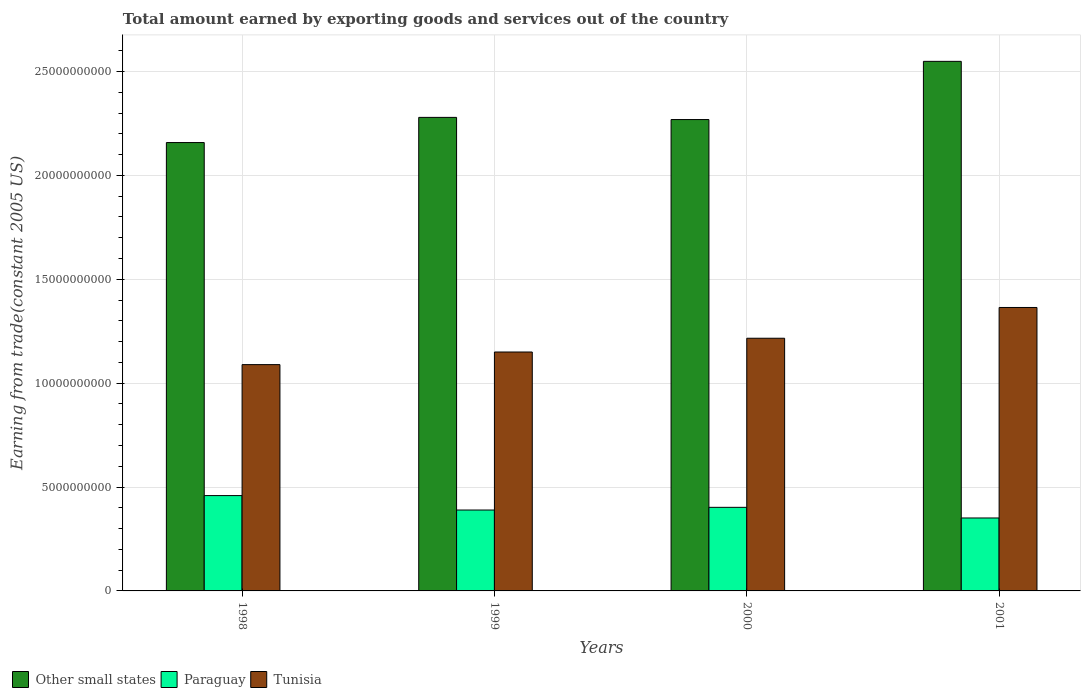How many different coloured bars are there?
Your answer should be very brief. 3. How many groups of bars are there?
Your response must be concise. 4. Are the number of bars per tick equal to the number of legend labels?
Your response must be concise. Yes. Are the number of bars on each tick of the X-axis equal?
Give a very brief answer. Yes. How many bars are there on the 2nd tick from the left?
Ensure brevity in your answer.  3. What is the label of the 4th group of bars from the left?
Give a very brief answer. 2001. What is the total amount earned by exporting goods and services in Other small states in 2000?
Offer a terse response. 2.27e+1. Across all years, what is the maximum total amount earned by exporting goods and services in Tunisia?
Your answer should be compact. 1.36e+1. Across all years, what is the minimum total amount earned by exporting goods and services in Tunisia?
Your response must be concise. 1.09e+1. In which year was the total amount earned by exporting goods and services in Tunisia maximum?
Keep it short and to the point. 2001. In which year was the total amount earned by exporting goods and services in Other small states minimum?
Your answer should be compact. 1998. What is the total total amount earned by exporting goods and services in Paraguay in the graph?
Offer a terse response. 1.60e+1. What is the difference between the total amount earned by exporting goods and services in Paraguay in 1998 and that in 1999?
Give a very brief answer. 6.95e+08. What is the difference between the total amount earned by exporting goods and services in Other small states in 2000 and the total amount earned by exporting goods and services in Tunisia in 1998?
Your answer should be compact. 1.18e+1. What is the average total amount earned by exporting goods and services in Paraguay per year?
Your answer should be very brief. 4.00e+09. In the year 2001, what is the difference between the total amount earned by exporting goods and services in Tunisia and total amount earned by exporting goods and services in Other small states?
Offer a very short reply. -1.18e+1. In how many years, is the total amount earned by exporting goods and services in Other small states greater than 1000000000 US$?
Your answer should be compact. 4. What is the ratio of the total amount earned by exporting goods and services in Paraguay in 1998 to that in 2000?
Your answer should be compact. 1.14. Is the total amount earned by exporting goods and services in Paraguay in 1999 less than that in 2001?
Your response must be concise. No. What is the difference between the highest and the second highest total amount earned by exporting goods and services in Tunisia?
Ensure brevity in your answer.  1.48e+09. What is the difference between the highest and the lowest total amount earned by exporting goods and services in Tunisia?
Offer a terse response. 2.75e+09. In how many years, is the total amount earned by exporting goods and services in Other small states greater than the average total amount earned by exporting goods and services in Other small states taken over all years?
Ensure brevity in your answer.  1. Is the sum of the total amount earned by exporting goods and services in Paraguay in 1998 and 2000 greater than the maximum total amount earned by exporting goods and services in Other small states across all years?
Your answer should be very brief. No. What does the 3rd bar from the left in 2001 represents?
Make the answer very short. Tunisia. What does the 3rd bar from the right in 1999 represents?
Ensure brevity in your answer.  Other small states. Are all the bars in the graph horizontal?
Offer a very short reply. No. How many years are there in the graph?
Your response must be concise. 4. Does the graph contain any zero values?
Ensure brevity in your answer.  No. Where does the legend appear in the graph?
Offer a terse response. Bottom left. How are the legend labels stacked?
Offer a very short reply. Horizontal. What is the title of the graph?
Keep it short and to the point. Total amount earned by exporting goods and services out of the country. What is the label or title of the Y-axis?
Keep it short and to the point. Earning from trade(constant 2005 US). What is the Earning from trade(constant 2005 US) in Other small states in 1998?
Offer a very short reply. 2.16e+1. What is the Earning from trade(constant 2005 US) in Paraguay in 1998?
Keep it short and to the point. 4.59e+09. What is the Earning from trade(constant 2005 US) in Tunisia in 1998?
Offer a very short reply. 1.09e+1. What is the Earning from trade(constant 2005 US) of Other small states in 1999?
Your response must be concise. 2.28e+1. What is the Earning from trade(constant 2005 US) in Paraguay in 1999?
Provide a succinct answer. 3.89e+09. What is the Earning from trade(constant 2005 US) of Tunisia in 1999?
Offer a very short reply. 1.15e+1. What is the Earning from trade(constant 2005 US) in Other small states in 2000?
Your response must be concise. 2.27e+1. What is the Earning from trade(constant 2005 US) of Paraguay in 2000?
Offer a terse response. 4.02e+09. What is the Earning from trade(constant 2005 US) of Tunisia in 2000?
Provide a succinct answer. 1.22e+1. What is the Earning from trade(constant 2005 US) in Other small states in 2001?
Your answer should be compact. 2.55e+1. What is the Earning from trade(constant 2005 US) in Paraguay in 2001?
Provide a short and direct response. 3.51e+09. What is the Earning from trade(constant 2005 US) of Tunisia in 2001?
Your response must be concise. 1.36e+1. Across all years, what is the maximum Earning from trade(constant 2005 US) in Other small states?
Ensure brevity in your answer.  2.55e+1. Across all years, what is the maximum Earning from trade(constant 2005 US) of Paraguay?
Your answer should be compact. 4.59e+09. Across all years, what is the maximum Earning from trade(constant 2005 US) in Tunisia?
Keep it short and to the point. 1.36e+1. Across all years, what is the minimum Earning from trade(constant 2005 US) in Other small states?
Offer a terse response. 2.16e+1. Across all years, what is the minimum Earning from trade(constant 2005 US) in Paraguay?
Give a very brief answer. 3.51e+09. Across all years, what is the minimum Earning from trade(constant 2005 US) of Tunisia?
Ensure brevity in your answer.  1.09e+1. What is the total Earning from trade(constant 2005 US) in Other small states in the graph?
Give a very brief answer. 9.25e+1. What is the total Earning from trade(constant 2005 US) of Paraguay in the graph?
Give a very brief answer. 1.60e+1. What is the total Earning from trade(constant 2005 US) of Tunisia in the graph?
Your answer should be very brief. 4.82e+1. What is the difference between the Earning from trade(constant 2005 US) in Other small states in 1998 and that in 1999?
Keep it short and to the point. -1.21e+09. What is the difference between the Earning from trade(constant 2005 US) in Paraguay in 1998 and that in 1999?
Offer a very short reply. 6.95e+08. What is the difference between the Earning from trade(constant 2005 US) of Tunisia in 1998 and that in 1999?
Your answer should be compact. -6.07e+08. What is the difference between the Earning from trade(constant 2005 US) of Other small states in 1998 and that in 2000?
Offer a terse response. -1.11e+09. What is the difference between the Earning from trade(constant 2005 US) in Paraguay in 1998 and that in 2000?
Provide a succinct answer. 5.66e+08. What is the difference between the Earning from trade(constant 2005 US) of Tunisia in 1998 and that in 2000?
Make the answer very short. -1.27e+09. What is the difference between the Earning from trade(constant 2005 US) in Other small states in 1998 and that in 2001?
Make the answer very short. -3.91e+09. What is the difference between the Earning from trade(constant 2005 US) in Paraguay in 1998 and that in 2001?
Keep it short and to the point. 1.08e+09. What is the difference between the Earning from trade(constant 2005 US) in Tunisia in 1998 and that in 2001?
Provide a short and direct response. -2.75e+09. What is the difference between the Earning from trade(constant 2005 US) of Other small states in 1999 and that in 2000?
Your answer should be very brief. 1.05e+08. What is the difference between the Earning from trade(constant 2005 US) in Paraguay in 1999 and that in 2000?
Give a very brief answer. -1.29e+08. What is the difference between the Earning from trade(constant 2005 US) of Tunisia in 1999 and that in 2000?
Provide a short and direct response. -6.62e+08. What is the difference between the Earning from trade(constant 2005 US) of Other small states in 1999 and that in 2001?
Your answer should be compact. -2.70e+09. What is the difference between the Earning from trade(constant 2005 US) in Paraguay in 1999 and that in 2001?
Give a very brief answer. 3.82e+08. What is the difference between the Earning from trade(constant 2005 US) in Tunisia in 1999 and that in 2001?
Ensure brevity in your answer.  -2.14e+09. What is the difference between the Earning from trade(constant 2005 US) in Other small states in 2000 and that in 2001?
Offer a very short reply. -2.80e+09. What is the difference between the Earning from trade(constant 2005 US) of Paraguay in 2000 and that in 2001?
Keep it short and to the point. 5.12e+08. What is the difference between the Earning from trade(constant 2005 US) of Tunisia in 2000 and that in 2001?
Your response must be concise. -1.48e+09. What is the difference between the Earning from trade(constant 2005 US) in Other small states in 1998 and the Earning from trade(constant 2005 US) in Paraguay in 1999?
Ensure brevity in your answer.  1.77e+1. What is the difference between the Earning from trade(constant 2005 US) of Other small states in 1998 and the Earning from trade(constant 2005 US) of Tunisia in 1999?
Offer a terse response. 1.01e+1. What is the difference between the Earning from trade(constant 2005 US) in Paraguay in 1998 and the Earning from trade(constant 2005 US) in Tunisia in 1999?
Your response must be concise. -6.91e+09. What is the difference between the Earning from trade(constant 2005 US) of Other small states in 1998 and the Earning from trade(constant 2005 US) of Paraguay in 2000?
Your answer should be compact. 1.76e+1. What is the difference between the Earning from trade(constant 2005 US) of Other small states in 1998 and the Earning from trade(constant 2005 US) of Tunisia in 2000?
Offer a terse response. 9.42e+09. What is the difference between the Earning from trade(constant 2005 US) of Paraguay in 1998 and the Earning from trade(constant 2005 US) of Tunisia in 2000?
Provide a succinct answer. -7.57e+09. What is the difference between the Earning from trade(constant 2005 US) in Other small states in 1998 and the Earning from trade(constant 2005 US) in Paraguay in 2001?
Your response must be concise. 1.81e+1. What is the difference between the Earning from trade(constant 2005 US) in Other small states in 1998 and the Earning from trade(constant 2005 US) in Tunisia in 2001?
Provide a short and direct response. 7.94e+09. What is the difference between the Earning from trade(constant 2005 US) of Paraguay in 1998 and the Earning from trade(constant 2005 US) of Tunisia in 2001?
Offer a very short reply. -9.05e+09. What is the difference between the Earning from trade(constant 2005 US) of Other small states in 1999 and the Earning from trade(constant 2005 US) of Paraguay in 2000?
Keep it short and to the point. 1.88e+1. What is the difference between the Earning from trade(constant 2005 US) of Other small states in 1999 and the Earning from trade(constant 2005 US) of Tunisia in 2000?
Offer a very short reply. 1.06e+1. What is the difference between the Earning from trade(constant 2005 US) in Paraguay in 1999 and the Earning from trade(constant 2005 US) in Tunisia in 2000?
Your answer should be very brief. -8.27e+09. What is the difference between the Earning from trade(constant 2005 US) of Other small states in 1999 and the Earning from trade(constant 2005 US) of Paraguay in 2001?
Provide a short and direct response. 1.93e+1. What is the difference between the Earning from trade(constant 2005 US) in Other small states in 1999 and the Earning from trade(constant 2005 US) in Tunisia in 2001?
Give a very brief answer. 9.15e+09. What is the difference between the Earning from trade(constant 2005 US) in Paraguay in 1999 and the Earning from trade(constant 2005 US) in Tunisia in 2001?
Provide a succinct answer. -9.75e+09. What is the difference between the Earning from trade(constant 2005 US) of Other small states in 2000 and the Earning from trade(constant 2005 US) of Paraguay in 2001?
Your response must be concise. 1.92e+1. What is the difference between the Earning from trade(constant 2005 US) of Other small states in 2000 and the Earning from trade(constant 2005 US) of Tunisia in 2001?
Your answer should be compact. 9.04e+09. What is the difference between the Earning from trade(constant 2005 US) of Paraguay in 2000 and the Earning from trade(constant 2005 US) of Tunisia in 2001?
Your answer should be very brief. -9.62e+09. What is the average Earning from trade(constant 2005 US) of Other small states per year?
Give a very brief answer. 2.31e+1. What is the average Earning from trade(constant 2005 US) of Paraguay per year?
Your answer should be compact. 4.00e+09. What is the average Earning from trade(constant 2005 US) of Tunisia per year?
Your answer should be compact. 1.20e+1. In the year 1998, what is the difference between the Earning from trade(constant 2005 US) of Other small states and Earning from trade(constant 2005 US) of Paraguay?
Offer a terse response. 1.70e+1. In the year 1998, what is the difference between the Earning from trade(constant 2005 US) in Other small states and Earning from trade(constant 2005 US) in Tunisia?
Give a very brief answer. 1.07e+1. In the year 1998, what is the difference between the Earning from trade(constant 2005 US) of Paraguay and Earning from trade(constant 2005 US) of Tunisia?
Your answer should be very brief. -6.30e+09. In the year 1999, what is the difference between the Earning from trade(constant 2005 US) in Other small states and Earning from trade(constant 2005 US) in Paraguay?
Give a very brief answer. 1.89e+1. In the year 1999, what is the difference between the Earning from trade(constant 2005 US) of Other small states and Earning from trade(constant 2005 US) of Tunisia?
Offer a terse response. 1.13e+1. In the year 1999, what is the difference between the Earning from trade(constant 2005 US) of Paraguay and Earning from trade(constant 2005 US) of Tunisia?
Your answer should be very brief. -7.61e+09. In the year 2000, what is the difference between the Earning from trade(constant 2005 US) in Other small states and Earning from trade(constant 2005 US) in Paraguay?
Make the answer very short. 1.87e+1. In the year 2000, what is the difference between the Earning from trade(constant 2005 US) of Other small states and Earning from trade(constant 2005 US) of Tunisia?
Your answer should be very brief. 1.05e+1. In the year 2000, what is the difference between the Earning from trade(constant 2005 US) in Paraguay and Earning from trade(constant 2005 US) in Tunisia?
Offer a terse response. -8.14e+09. In the year 2001, what is the difference between the Earning from trade(constant 2005 US) in Other small states and Earning from trade(constant 2005 US) in Paraguay?
Provide a succinct answer. 2.20e+1. In the year 2001, what is the difference between the Earning from trade(constant 2005 US) of Other small states and Earning from trade(constant 2005 US) of Tunisia?
Give a very brief answer. 1.18e+1. In the year 2001, what is the difference between the Earning from trade(constant 2005 US) of Paraguay and Earning from trade(constant 2005 US) of Tunisia?
Keep it short and to the point. -1.01e+1. What is the ratio of the Earning from trade(constant 2005 US) of Other small states in 1998 to that in 1999?
Offer a terse response. 0.95. What is the ratio of the Earning from trade(constant 2005 US) in Paraguay in 1998 to that in 1999?
Provide a succinct answer. 1.18. What is the ratio of the Earning from trade(constant 2005 US) in Tunisia in 1998 to that in 1999?
Your answer should be very brief. 0.95. What is the ratio of the Earning from trade(constant 2005 US) in Other small states in 1998 to that in 2000?
Provide a short and direct response. 0.95. What is the ratio of the Earning from trade(constant 2005 US) in Paraguay in 1998 to that in 2000?
Your answer should be very brief. 1.14. What is the ratio of the Earning from trade(constant 2005 US) of Tunisia in 1998 to that in 2000?
Make the answer very short. 0.9. What is the ratio of the Earning from trade(constant 2005 US) in Other small states in 1998 to that in 2001?
Provide a short and direct response. 0.85. What is the ratio of the Earning from trade(constant 2005 US) of Paraguay in 1998 to that in 2001?
Your response must be concise. 1.31. What is the ratio of the Earning from trade(constant 2005 US) in Tunisia in 1998 to that in 2001?
Your answer should be very brief. 0.8. What is the ratio of the Earning from trade(constant 2005 US) in Other small states in 1999 to that in 2000?
Keep it short and to the point. 1. What is the ratio of the Earning from trade(constant 2005 US) in Paraguay in 1999 to that in 2000?
Offer a very short reply. 0.97. What is the ratio of the Earning from trade(constant 2005 US) of Tunisia in 1999 to that in 2000?
Ensure brevity in your answer.  0.95. What is the ratio of the Earning from trade(constant 2005 US) in Other small states in 1999 to that in 2001?
Provide a short and direct response. 0.89. What is the ratio of the Earning from trade(constant 2005 US) in Paraguay in 1999 to that in 2001?
Keep it short and to the point. 1.11. What is the ratio of the Earning from trade(constant 2005 US) in Tunisia in 1999 to that in 2001?
Make the answer very short. 0.84. What is the ratio of the Earning from trade(constant 2005 US) in Other small states in 2000 to that in 2001?
Your answer should be compact. 0.89. What is the ratio of the Earning from trade(constant 2005 US) of Paraguay in 2000 to that in 2001?
Provide a succinct answer. 1.15. What is the ratio of the Earning from trade(constant 2005 US) in Tunisia in 2000 to that in 2001?
Offer a terse response. 0.89. What is the difference between the highest and the second highest Earning from trade(constant 2005 US) of Other small states?
Keep it short and to the point. 2.70e+09. What is the difference between the highest and the second highest Earning from trade(constant 2005 US) in Paraguay?
Keep it short and to the point. 5.66e+08. What is the difference between the highest and the second highest Earning from trade(constant 2005 US) of Tunisia?
Offer a terse response. 1.48e+09. What is the difference between the highest and the lowest Earning from trade(constant 2005 US) in Other small states?
Make the answer very short. 3.91e+09. What is the difference between the highest and the lowest Earning from trade(constant 2005 US) in Paraguay?
Your answer should be very brief. 1.08e+09. What is the difference between the highest and the lowest Earning from trade(constant 2005 US) of Tunisia?
Your answer should be compact. 2.75e+09. 